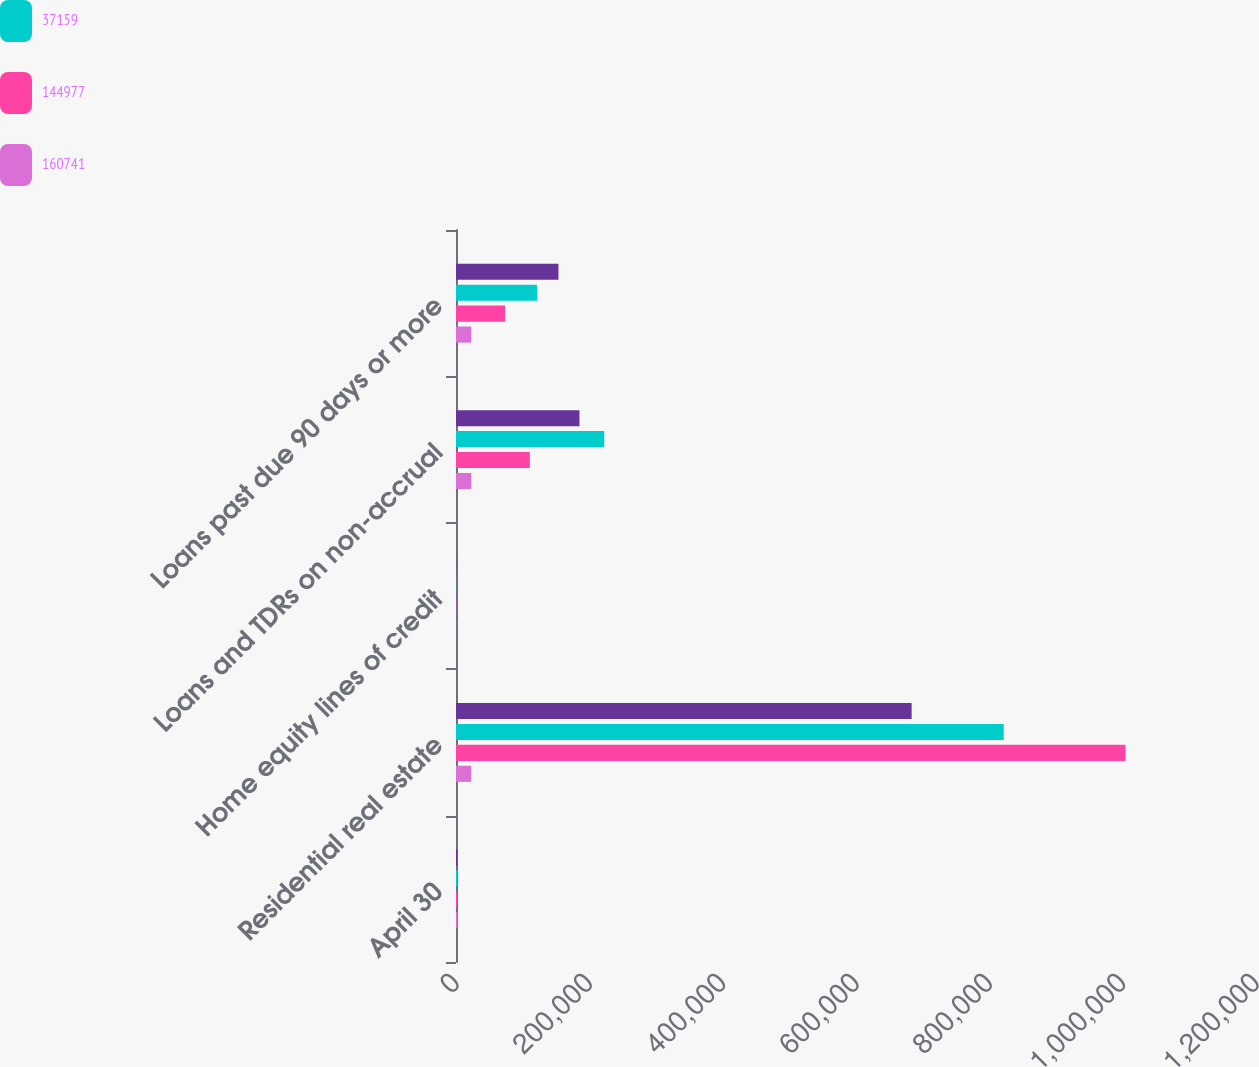Convert chart to OTSL. <chart><loc_0><loc_0><loc_500><loc_500><stacked_bar_chart><ecel><fcel>April 30<fcel>Residential real estate<fcel>Home equity lines of credit<fcel>Loans and TDRs on non-accrual<fcel>Loans past due 90 days or more<nl><fcel>nan<fcel>2010<fcel>683452<fcel>232<fcel>185209<fcel>153703<nl><fcel>37159<fcel>2009<fcel>821583<fcel>254<fcel>222382<fcel>121685<nl><fcel>144977<fcel>2008<fcel>1.00428e+06<fcel>357<fcel>110759<fcel>73600<nl><fcel>160741<fcel>2007<fcel>22909<fcel>280<fcel>22909<fcel>22909<nl></chart> 